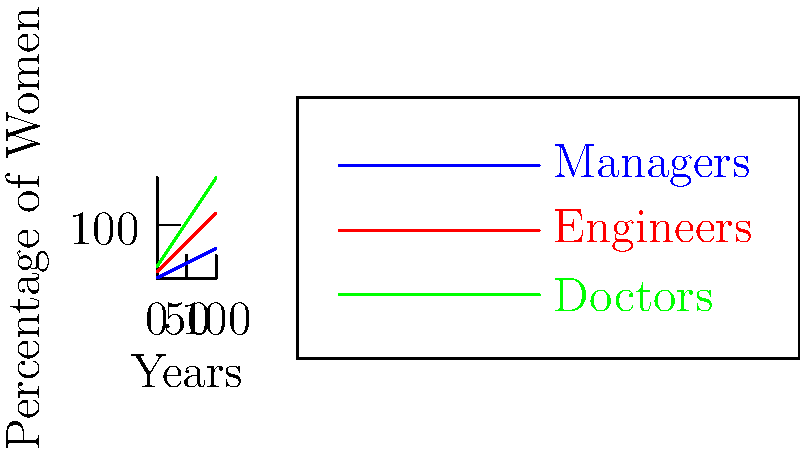Based on the graph showing the representation of women in different professions over time, which profession is projected to have the highest percentage of women after 100 years? To determine which profession will have the highest percentage of women after 100 years, we need to analyze the growth rates and starting points for each profession:

1. Managers (blue line):
   - Starts at 10%
   - Grows by 0.5% per year
   - After 100 years: $10\% + (0.5\% \times 100) = 60\%$

2. Engineers (red line):
   - Starts at 20%
   - Grows by 1% per year
   - After 100 years: $20\% + (1\% \times 100) = 120\%$

3. Doctors (green line):
   - Starts at 30%
   - Grows by 1.5% per year
   - After 100 years: $30\% + (1.5\% \times 100) = 180\%$

Comparing the final percentages:
- Managers: 60%
- Engineers: 120%
- Doctors: 180%

The profession with the highest percentage of women after 100 years is Doctors at 180%.
Answer: Doctors 